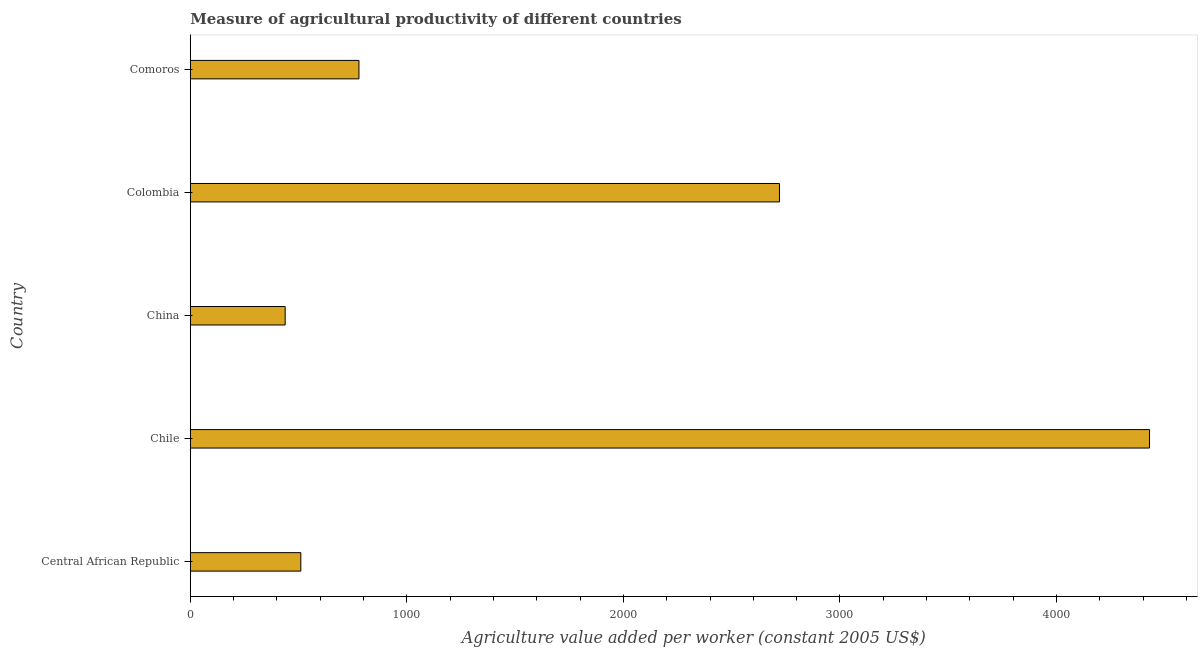Does the graph contain any zero values?
Your answer should be compact. No. Does the graph contain grids?
Provide a short and direct response. No. What is the title of the graph?
Your response must be concise. Measure of agricultural productivity of different countries. What is the label or title of the X-axis?
Provide a succinct answer. Agriculture value added per worker (constant 2005 US$). What is the label or title of the Y-axis?
Provide a succinct answer. Country. What is the agriculture value added per worker in Central African Republic?
Give a very brief answer. 510.33. Across all countries, what is the maximum agriculture value added per worker?
Your response must be concise. 4429.45. Across all countries, what is the minimum agriculture value added per worker?
Give a very brief answer. 438.12. In which country was the agriculture value added per worker maximum?
Offer a terse response. Chile. In which country was the agriculture value added per worker minimum?
Give a very brief answer. China. What is the sum of the agriculture value added per worker?
Provide a short and direct response. 8877.26. What is the difference between the agriculture value added per worker in China and Colombia?
Your response must be concise. -2282.41. What is the average agriculture value added per worker per country?
Your answer should be compact. 1775.45. What is the median agriculture value added per worker?
Your answer should be very brief. 778.83. In how many countries, is the agriculture value added per worker greater than 3200 US$?
Your answer should be very brief. 1. What is the ratio of the agriculture value added per worker in Central African Republic to that in Comoros?
Your response must be concise. 0.66. Is the difference between the agriculture value added per worker in China and Colombia greater than the difference between any two countries?
Provide a succinct answer. No. What is the difference between the highest and the second highest agriculture value added per worker?
Your response must be concise. 1708.92. What is the difference between the highest and the lowest agriculture value added per worker?
Your answer should be compact. 3991.33. How many bars are there?
Make the answer very short. 5. Are all the bars in the graph horizontal?
Offer a terse response. Yes. How many countries are there in the graph?
Your answer should be compact. 5. What is the difference between two consecutive major ticks on the X-axis?
Ensure brevity in your answer.  1000. Are the values on the major ticks of X-axis written in scientific E-notation?
Provide a short and direct response. No. What is the Agriculture value added per worker (constant 2005 US$) of Central African Republic?
Ensure brevity in your answer.  510.33. What is the Agriculture value added per worker (constant 2005 US$) in Chile?
Give a very brief answer. 4429.45. What is the Agriculture value added per worker (constant 2005 US$) of China?
Make the answer very short. 438.12. What is the Agriculture value added per worker (constant 2005 US$) in Colombia?
Your answer should be compact. 2720.53. What is the Agriculture value added per worker (constant 2005 US$) of Comoros?
Your answer should be very brief. 778.83. What is the difference between the Agriculture value added per worker (constant 2005 US$) in Central African Republic and Chile?
Provide a short and direct response. -3919.13. What is the difference between the Agriculture value added per worker (constant 2005 US$) in Central African Republic and China?
Your answer should be compact. 72.2. What is the difference between the Agriculture value added per worker (constant 2005 US$) in Central African Republic and Colombia?
Your answer should be very brief. -2210.2. What is the difference between the Agriculture value added per worker (constant 2005 US$) in Central African Republic and Comoros?
Keep it short and to the point. -268.51. What is the difference between the Agriculture value added per worker (constant 2005 US$) in Chile and China?
Provide a succinct answer. 3991.33. What is the difference between the Agriculture value added per worker (constant 2005 US$) in Chile and Colombia?
Provide a succinct answer. 1708.92. What is the difference between the Agriculture value added per worker (constant 2005 US$) in Chile and Comoros?
Keep it short and to the point. 3650.62. What is the difference between the Agriculture value added per worker (constant 2005 US$) in China and Colombia?
Your answer should be compact. -2282.41. What is the difference between the Agriculture value added per worker (constant 2005 US$) in China and Comoros?
Offer a terse response. -340.71. What is the difference between the Agriculture value added per worker (constant 2005 US$) in Colombia and Comoros?
Keep it short and to the point. 1941.7. What is the ratio of the Agriculture value added per worker (constant 2005 US$) in Central African Republic to that in Chile?
Provide a succinct answer. 0.12. What is the ratio of the Agriculture value added per worker (constant 2005 US$) in Central African Republic to that in China?
Make the answer very short. 1.17. What is the ratio of the Agriculture value added per worker (constant 2005 US$) in Central African Republic to that in Colombia?
Your answer should be compact. 0.19. What is the ratio of the Agriculture value added per worker (constant 2005 US$) in Central African Republic to that in Comoros?
Give a very brief answer. 0.66. What is the ratio of the Agriculture value added per worker (constant 2005 US$) in Chile to that in China?
Provide a succinct answer. 10.11. What is the ratio of the Agriculture value added per worker (constant 2005 US$) in Chile to that in Colombia?
Offer a terse response. 1.63. What is the ratio of the Agriculture value added per worker (constant 2005 US$) in Chile to that in Comoros?
Provide a short and direct response. 5.69. What is the ratio of the Agriculture value added per worker (constant 2005 US$) in China to that in Colombia?
Provide a short and direct response. 0.16. What is the ratio of the Agriculture value added per worker (constant 2005 US$) in China to that in Comoros?
Your answer should be very brief. 0.56. What is the ratio of the Agriculture value added per worker (constant 2005 US$) in Colombia to that in Comoros?
Offer a terse response. 3.49. 